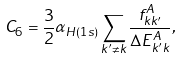Convert formula to latex. <formula><loc_0><loc_0><loc_500><loc_500>C _ { 6 } = \frac { 3 } { 2 } \alpha _ { H ( 1 s ) } \sum _ { k ^ { \prime } \neq k } \frac { f ^ { A } _ { k k ^ { \prime } } } { \Delta E _ { k ^ { \prime } k } ^ { A } } ,</formula> 